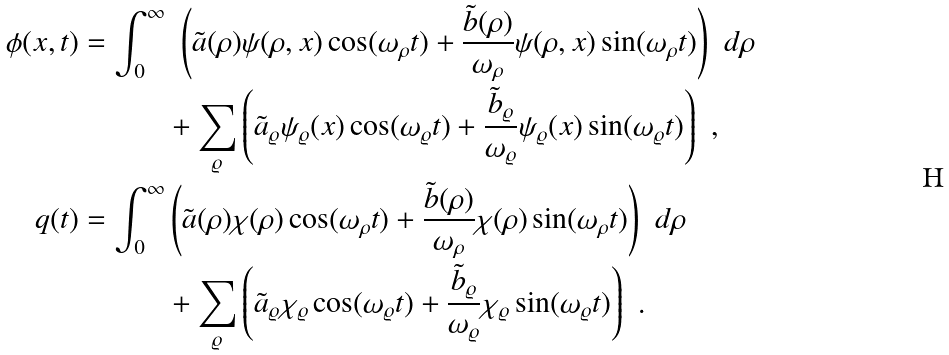<formula> <loc_0><loc_0><loc_500><loc_500>\phi ( x , t ) = \int _ { 0 } ^ { \infty } & \ \left ( \tilde { a } ( \rho ) \psi ( \rho , x ) \cos ( \omega _ { \rho } t ) + \frac { \tilde { b } ( \rho ) } { \omega _ { \rho } } \psi ( \rho , x ) \sin ( \omega _ { \rho } t ) \right ) \ d \rho \\ & + \sum _ { \varrho } \left ( \tilde { a } _ { \varrho } \psi _ { \varrho } ( x ) \cos ( \omega _ { \varrho } t ) + \frac { \tilde { b } _ { \varrho } } { \omega _ { \varrho } } \psi _ { \varrho } ( x ) \sin ( \omega _ { \varrho } t ) \right ) \ , \\ q ( t ) = \int _ { 0 } ^ { \infty } & \left ( \tilde { a } ( \rho ) \chi ( \rho ) \cos ( \omega _ { \rho } t ) + \frac { \tilde { b } ( \rho ) } { \omega _ { \rho } } \chi ( \rho ) \sin ( \omega _ { \rho } t ) \right ) \ d \rho \\ & + \sum _ { \varrho } \left ( \tilde { a } _ { \varrho } \chi _ { \varrho } \cos ( \omega _ { \varrho } t ) + \frac { \tilde { b } _ { \varrho } } { \omega _ { \varrho } } \chi _ { \varrho } \sin ( \omega _ { \varrho } t ) \right ) \ .</formula> 